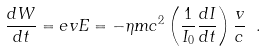Convert formula to latex. <formula><loc_0><loc_0><loc_500><loc_500>\frac { d W } { d t } = e v E = - \eta m c ^ { 2 } \left ( \frac { 1 } { I _ { 0 } } \frac { d I } { d t } \right ) \frac { v } { c } \ .</formula> 